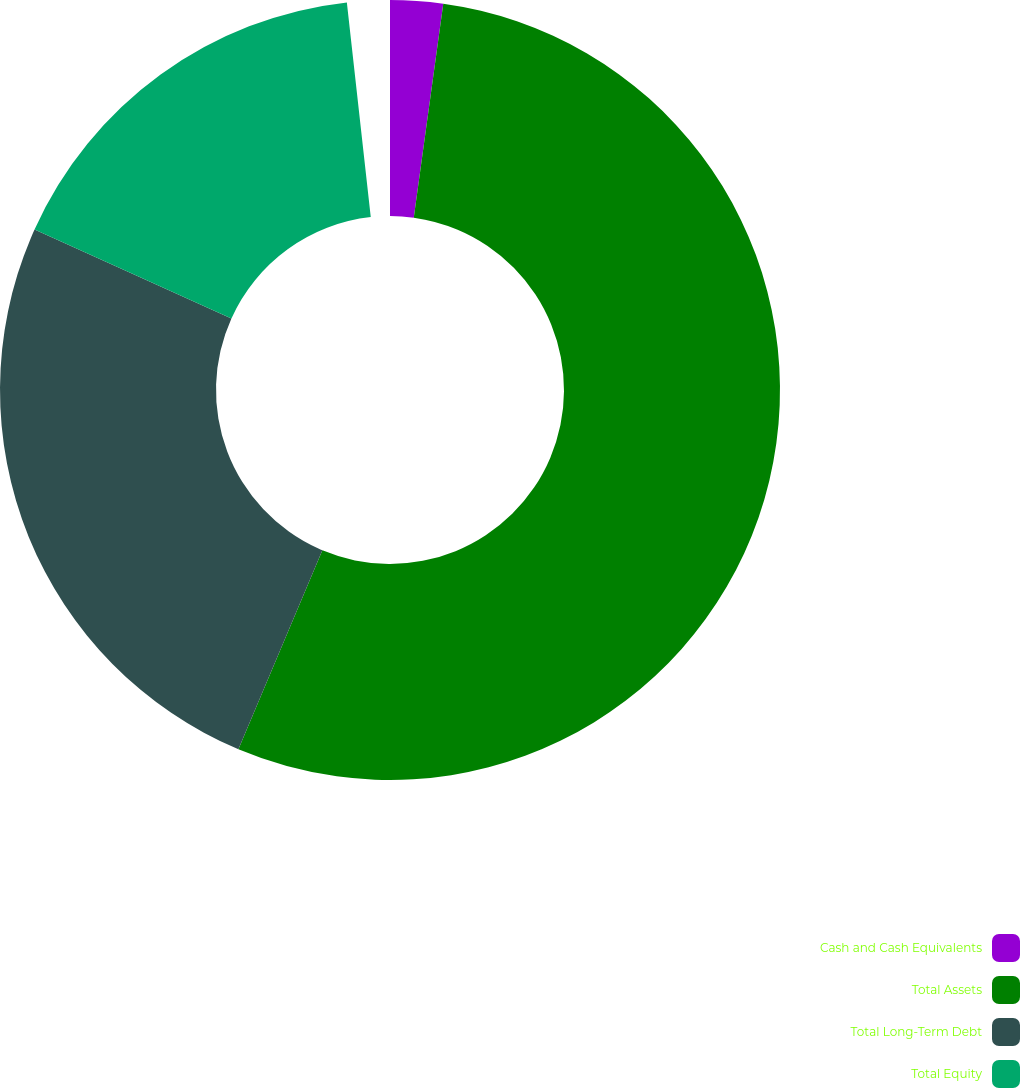<chart> <loc_0><loc_0><loc_500><loc_500><pie_chart><fcel>Cash and Cash Equivalents<fcel>Total Assets<fcel>Total Long-Term Debt<fcel>Total Equity<nl><fcel>2.22%<fcel>55.14%<fcel>25.85%<fcel>16.78%<nl></chart> 